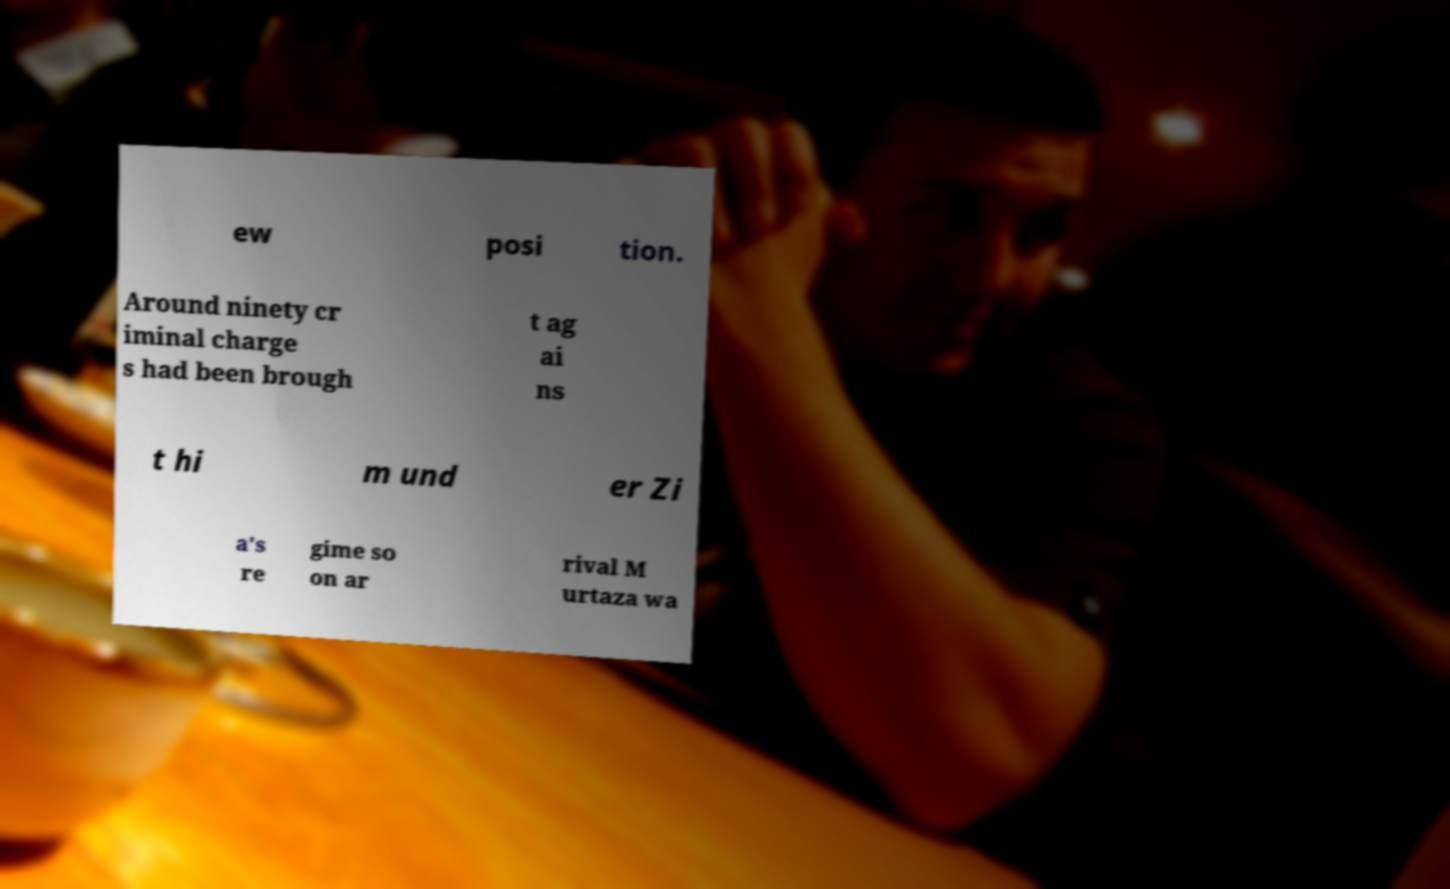What messages or text are displayed in this image? I need them in a readable, typed format. ew posi tion. Around ninety cr iminal charge s had been brough t ag ai ns t hi m und er Zi a's re gime so on ar rival M urtaza wa 